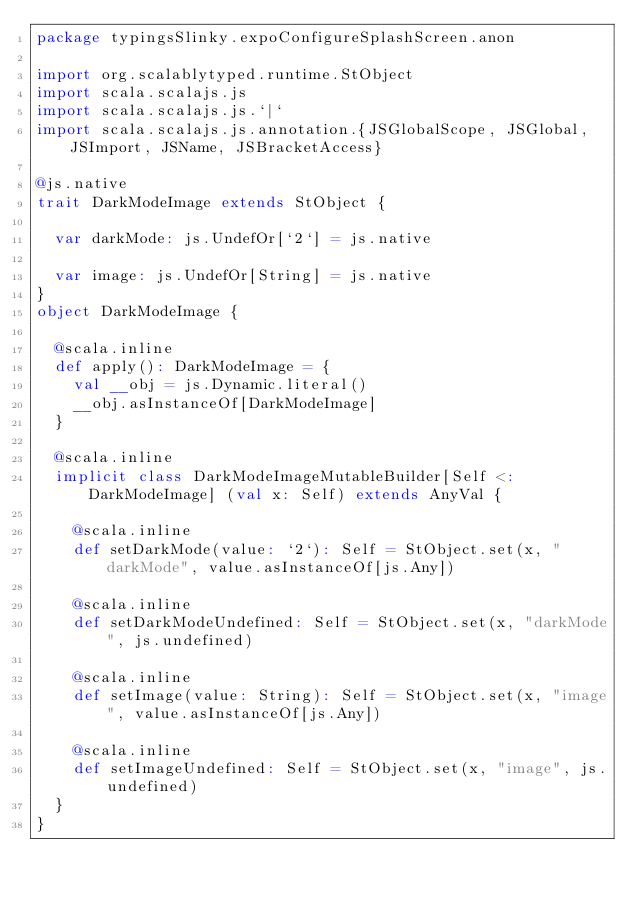Convert code to text. <code><loc_0><loc_0><loc_500><loc_500><_Scala_>package typingsSlinky.expoConfigureSplashScreen.anon

import org.scalablytyped.runtime.StObject
import scala.scalajs.js
import scala.scalajs.js.`|`
import scala.scalajs.js.annotation.{JSGlobalScope, JSGlobal, JSImport, JSName, JSBracketAccess}

@js.native
trait DarkModeImage extends StObject {
  
  var darkMode: js.UndefOr[`2`] = js.native
  
  var image: js.UndefOr[String] = js.native
}
object DarkModeImage {
  
  @scala.inline
  def apply(): DarkModeImage = {
    val __obj = js.Dynamic.literal()
    __obj.asInstanceOf[DarkModeImage]
  }
  
  @scala.inline
  implicit class DarkModeImageMutableBuilder[Self <: DarkModeImage] (val x: Self) extends AnyVal {
    
    @scala.inline
    def setDarkMode(value: `2`): Self = StObject.set(x, "darkMode", value.asInstanceOf[js.Any])
    
    @scala.inline
    def setDarkModeUndefined: Self = StObject.set(x, "darkMode", js.undefined)
    
    @scala.inline
    def setImage(value: String): Self = StObject.set(x, "image", value.asInstanceOf[js.Any])
    
    @scala.inline
    def setImageUndefined: Self = StObject.set(x, "image", js.undefined)
  }
}
</code> 